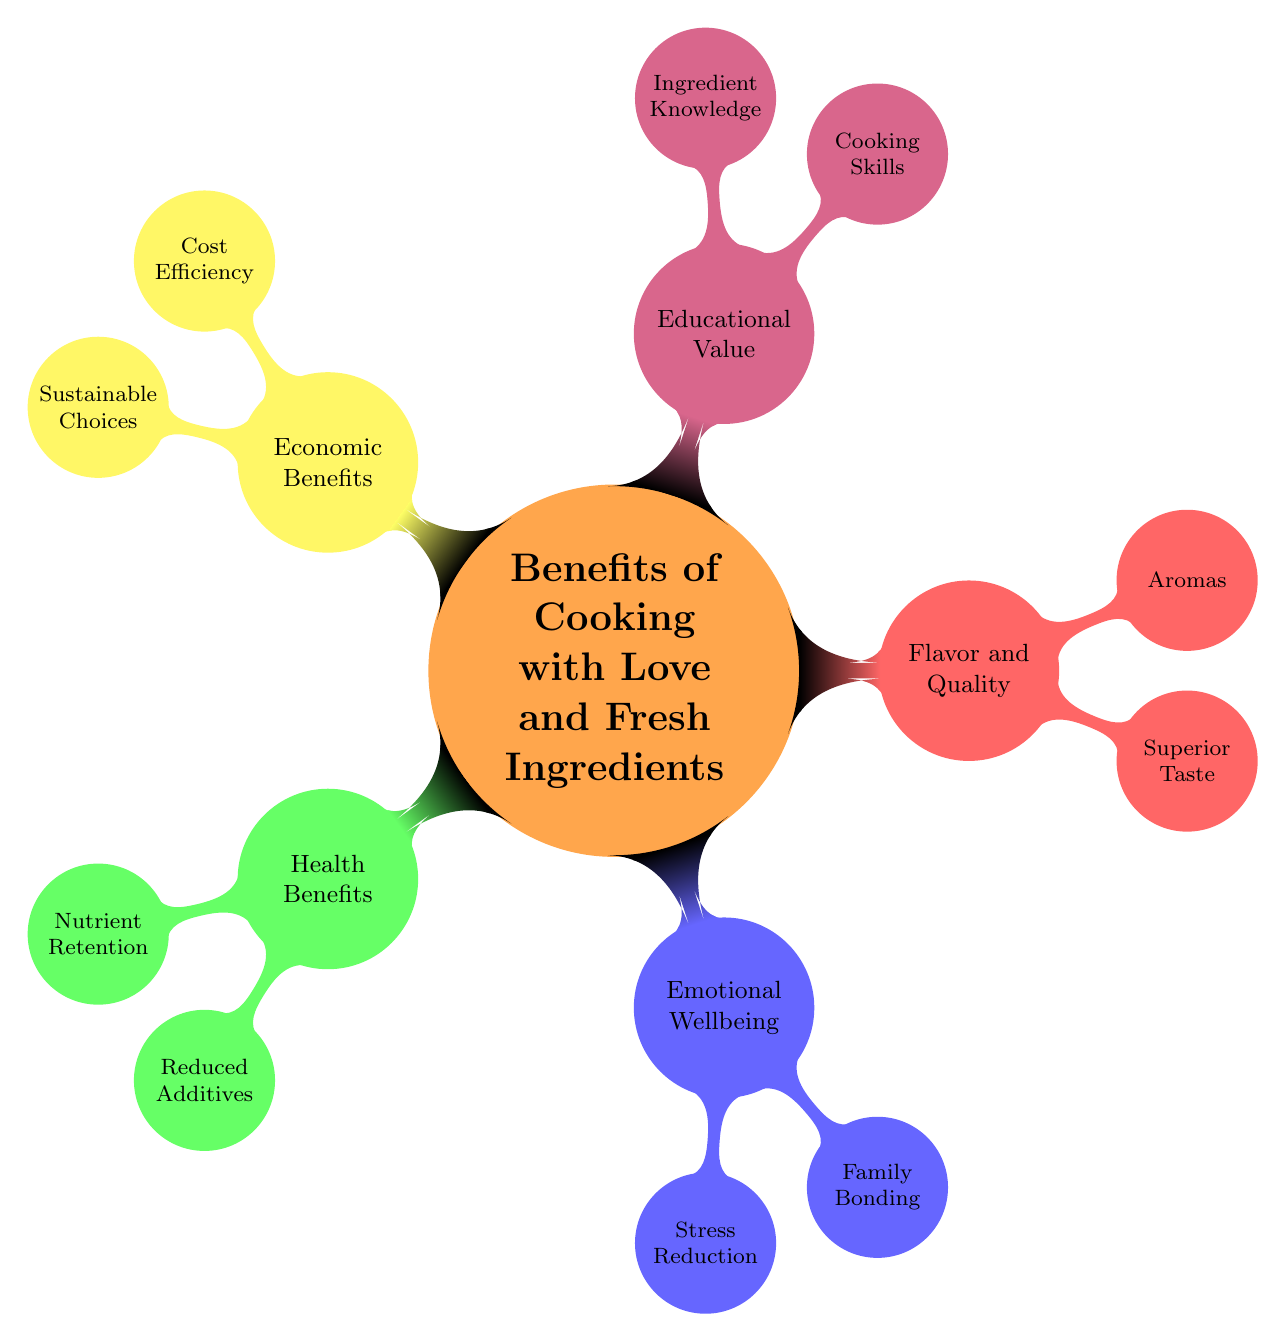What are the two main categories under "Health Benefits"? The diagram shows "Health Benefits" as one node with two child nodes: "Nutrient Retention" and "Reduced Additives".
Answer: Nutrient Retention, Reduced Additives How many child nodes does "Emotional Wellbeing" have? "Emotional Wellbeing" has two child nodes: "Stress Reduction" and "Family Bonding". Thus, it counts as two.
Answer: 2 What is a benefit of using fresh ingredients related to cooking skills? The diagram indicates "Cooking Skills" as a child node under "Educational Value", showing a connection between fresh ingredients and skill development in cooking.
Answer: Cooking Skills Which category includes "Cost Efficiency"? The diagram places "Cost Efficiency" under the category "Economic Benefits", which is one of the five main areas highlighted in the mind map.
Answer: Economic Benefits What are two emotional benefits listed in the diagram? Under "Emotional Wellbeing", the diagram lists "Stress Reduction" and "Family Bonding" as benefits, connecting emotional health to cooking practices.
Answer: Stress Reduction, Family Bonding How does "Cooking with Love" impact flavor according to the diagram? Under "Flavor and Quality", the diagram lists "Superior Taste" and "Aromas" as benefits of using fresh ingredients, suggesting that love in cooking enhances flavor and appeal.
Answer: Superior Taste, Aromas Which aspect connects cooking with local sustainability? The diagram categorizes "Sustainable Choices" under "Economic Benefits", indicating that using fresh ingredients can support local farmers and reduce waste.
Answer: Sustainable Choices What is the relationship between "Stress Reduction" and "Mindful Food Preparation"? The diagram implies that "Stress Reduction" is achieved through "Mindful Food Preparation", both of which fall under "Emotional Wellbeing".
Answer: Mindful Food Preparation What is one impact of fresh ingredients on nutrient retention? The diagram states "Preservation of vitamins and minerals in fresh produce", evidencing that fresh ingredients aid in retaining nutrients in meals.
Answer: Preservation of vitamins and minerals 